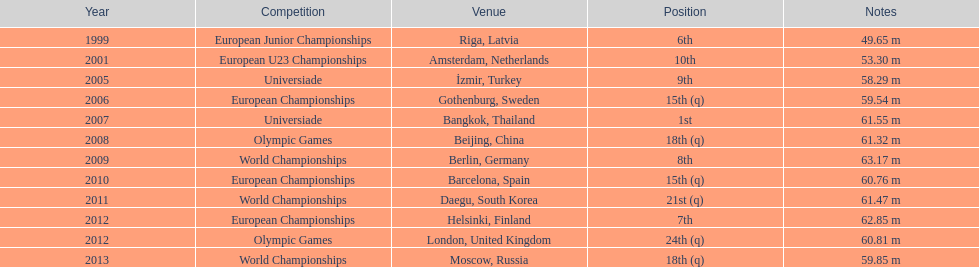During which years did gerhard mayer compete? 1999, 2001, 2005, 2006, 2007, 2008, 2009, 2010, 2011, 2012, 2012, 2013. Which years came before 2007? 1999, 2001, 2005, 2006. What was the top position for these years? 6th. 